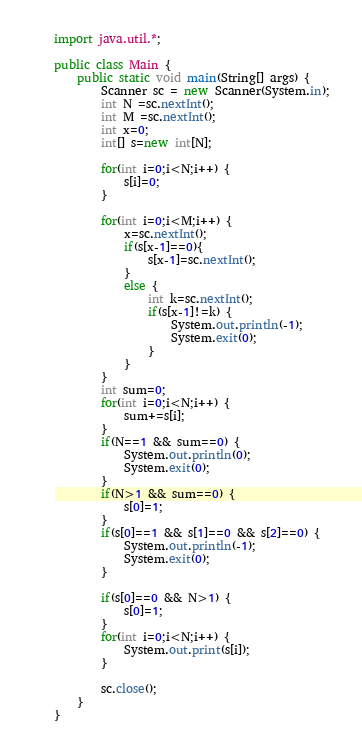Convert code to text. <code><loc_0><loc_0><loc_500><loc_500><_Java_>import java.util.*;

public class Main {
	public static void main(String[] args) {
		Scanner sc = new Scanner(System.in);
		int N =sc.nextInt();
		int M =sc.nextInt();
		int x=0;
		int[] s=new int[N];

		for(int i=0;i<N;i++) {
			s[i]=0;
		}
		
		for(int i=0;i<M;i++) {
			x=sc.nextInt();
			if(s[x-1]==0){
				s[x-1]=sc.nextInt();
			}
			else {
				int k=sc.nextInt();
				if(s[x-1]!=k) {
					System.out.println(-1);
					System.exit(0);
				}
			}
		}
		int sum=0;
		for(int i=0;i<N;i++) {
			sum+=s[i];
		}
		if(N==1 && sum==0) {
			System.out.println(0);
			System.exit(0);
		}
		if(N>1 && sum==0) {
			s[0]=1;
		}
		if(s[0]==1 && s[1]==0 && s[2]==0) {
			System.out.println(-1);
			System.exit(0);
		}
		
		if(s[0]==0 && N>1) {
			s[0]=1;
		}
		for(int i=0;i<N;i++) {
			System.out.print(s[i]);	
		}
		
		sc.close();
	}
}
</code> 